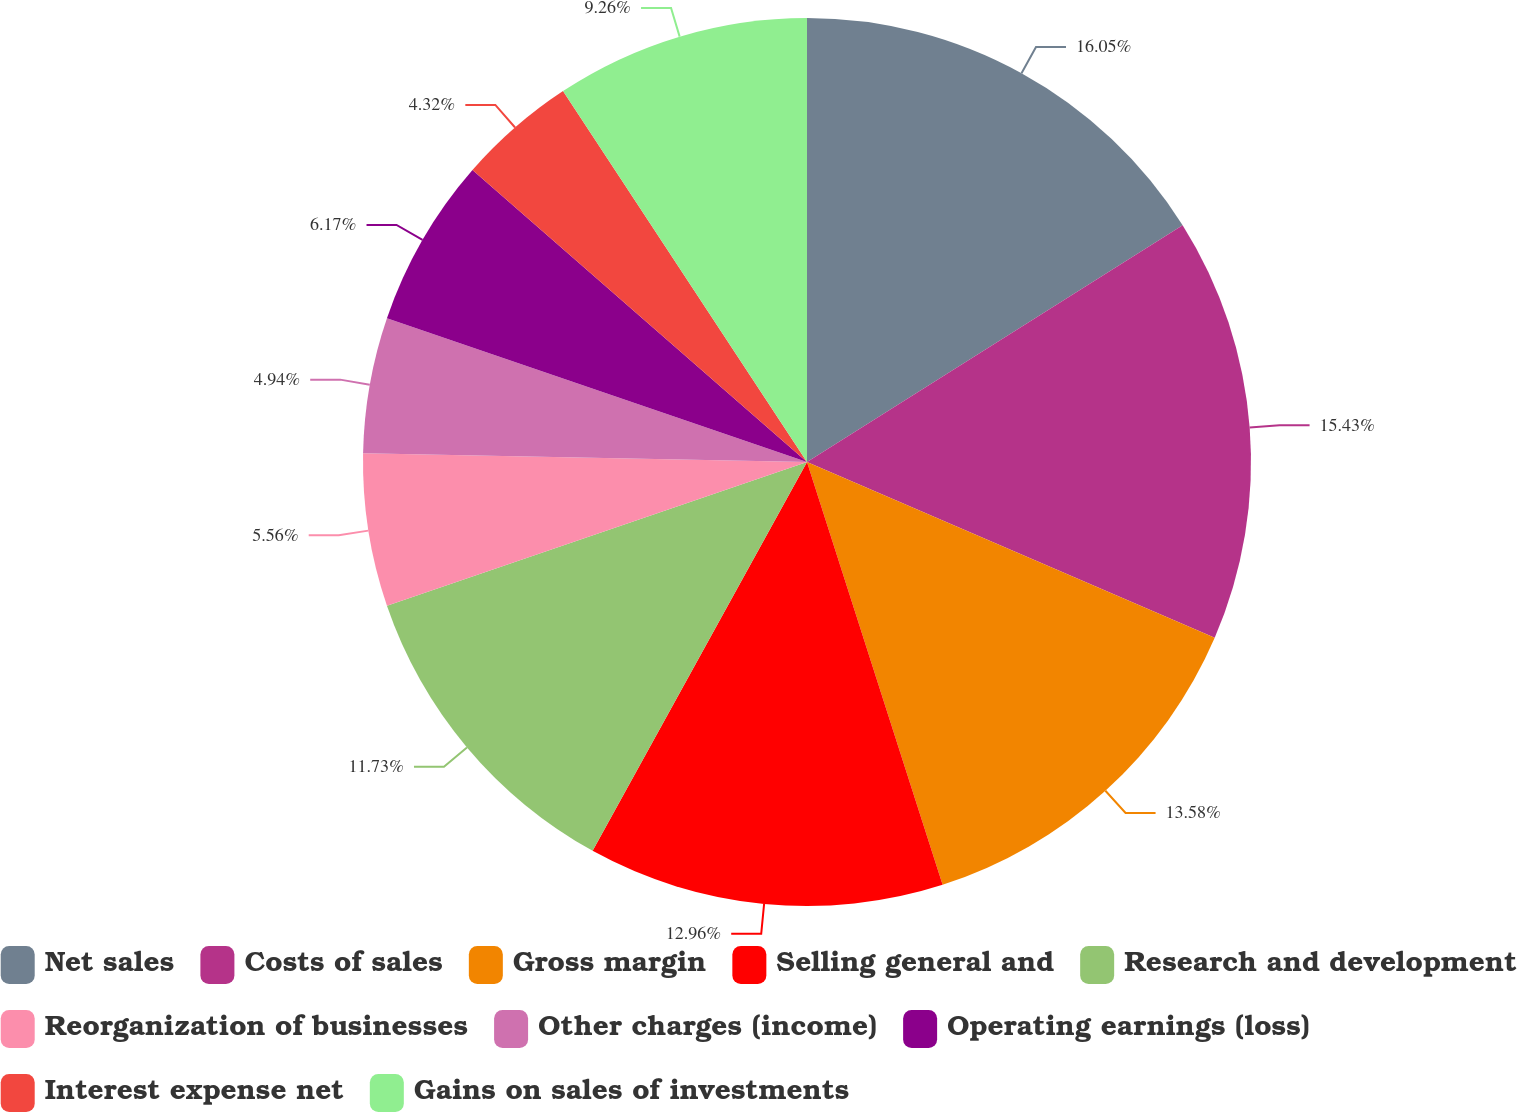Convert chart to OTSL. <chart><loc_0><loc_0><loc_500><loc_500><pie_chart><fcel>Net sales<fcel>Costs of sales<fcel>Gross margin<fcel>Selling general and<fcel>Research and development<fcel>Reorganization of businesses<fcel>Other charges (income)<fcel>Operating earnings (loss)<fcel>Interest expense net<fcel>Gains on sales of investments<nl><fcel>16.05%<fcel>15.43%<fcel>13.58%<fcel>12.96%<fcel>11.73%<fcel>5.56%<fcel>4.94%<fcel>6.17%<fcel>4.32%<fcel>9.26%<nl></chart> 